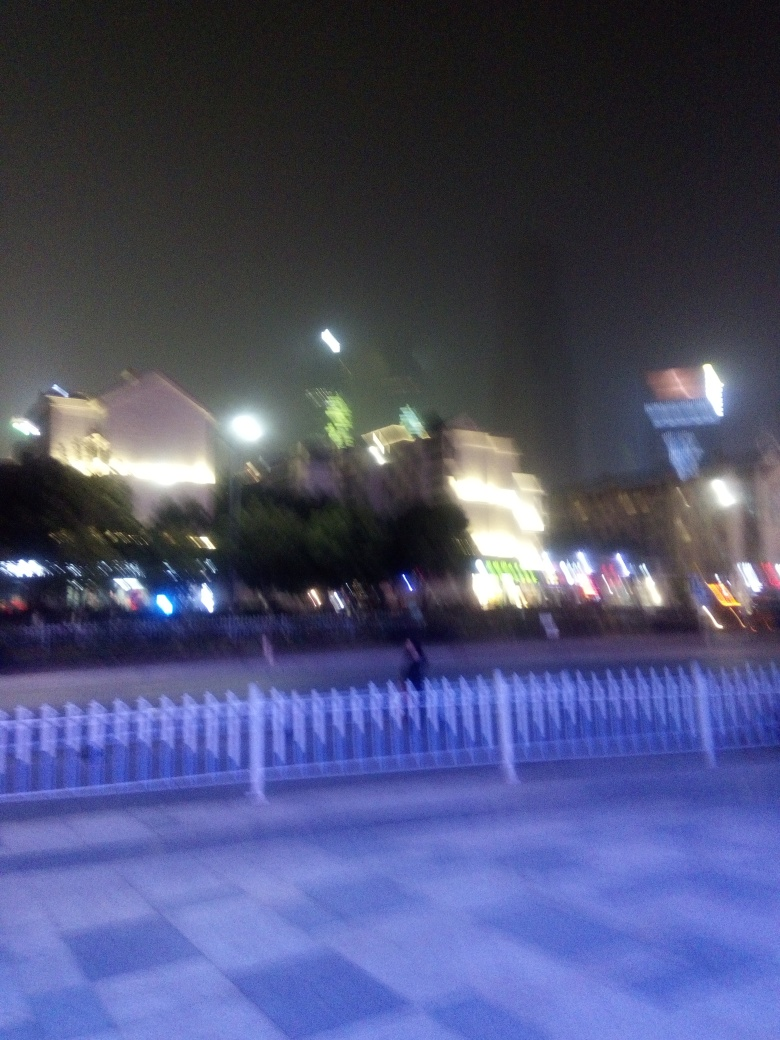It's nighttime in this photo. Can you tell what kind of area this might be? Based on the bright lights and the presence of signage, it appears to be an urban commercial area, possibly a downtown or city center where businesses and nightlife converge. 